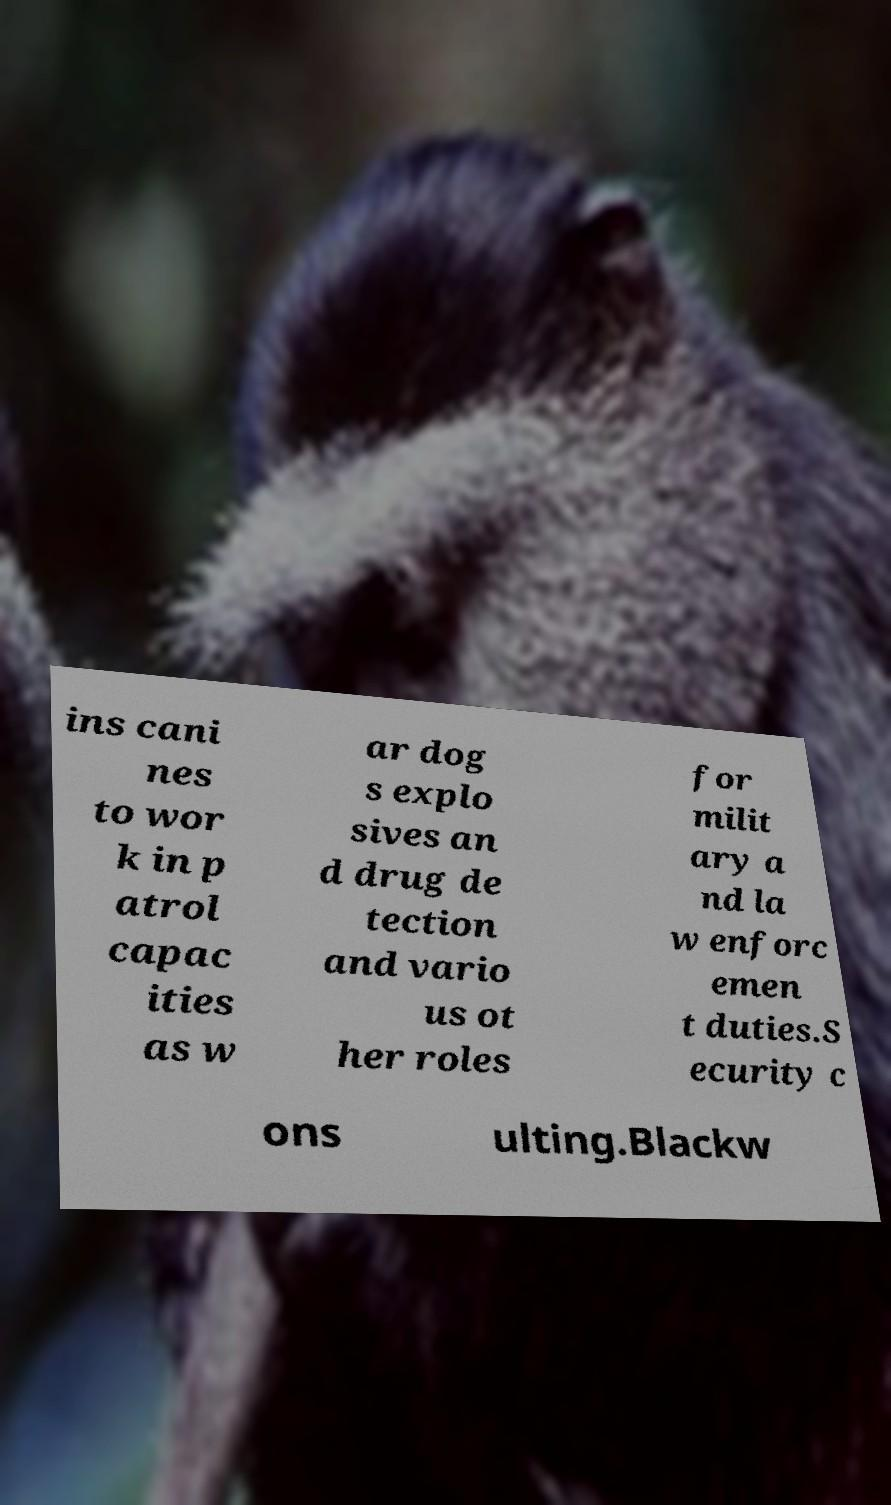Please read and relay the text visible in this image. What does it say? ins cani nes to wor k in p atrol capac ities as w ar dog s explo sives an d drug de tection and vario us ot her roles for milit ary a nd la w enforc emen t duties.S ecurity c ons ulting.Blackw 